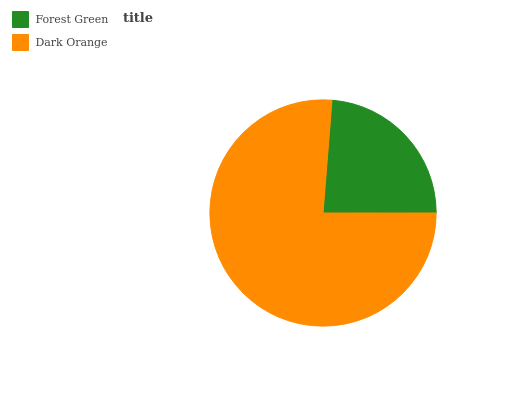Is Forest Green the minimum?
Answer yes or no. Yes. Is Dark Orange the maximum?
Answer yes or no. Yes. Is Dark Orange the minimum?
Answer yes or no. No. Is Dark Orange greater than Forest Green?
Answer yes or no. Yes. Is Forest Green less than Dark Orange?
Answer yes or no. Yes. Is Forest Green greater than Dark Orange?
Answer yes or no. No. Is Dark Orange less than Forest Green?
Answer yes or no. No. Is Dark Orange the high median?
Answer yes or no. Yes. Is Forest Green the low median?
Answer yes or no. Yes. Is Forest Green the high median?
Answer yes or no. No. Is Dark Orange the low median?
Answer yes or no. No. 